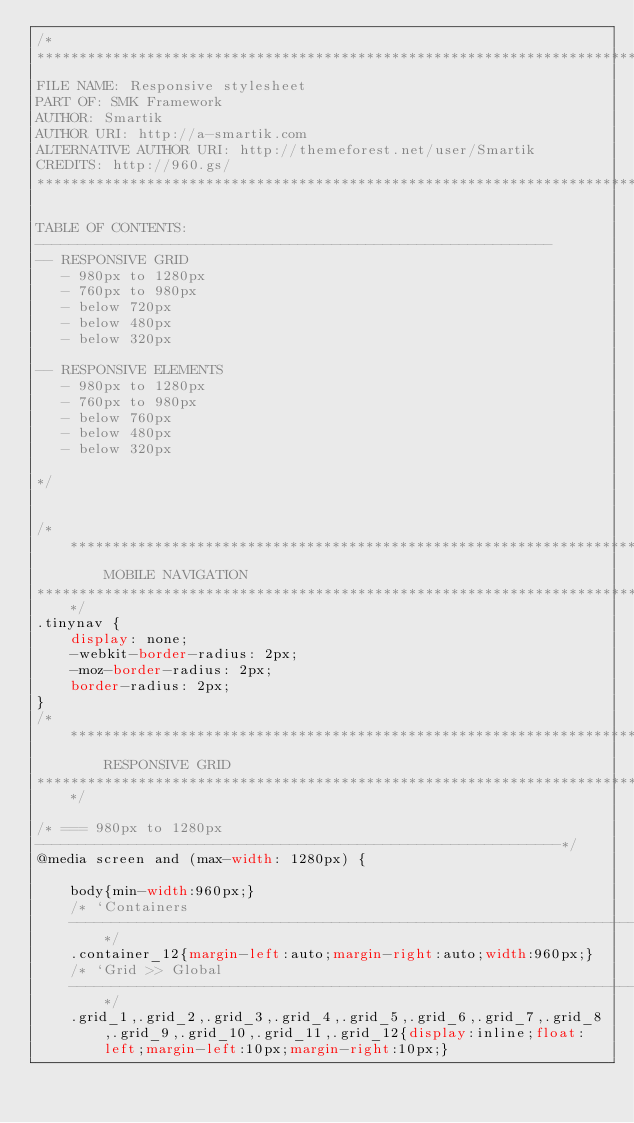Convert code to text. <code><loc_0><loc_0><loc_500><loc_500><_CSS_>/*
************************************************************************
FILE NAME: Responsive stylesheet
PART OF: SMK Framework
AUTHOR: Smartik
AUTHOR URI: http://a-smartik.com
ALTERNATIVE AUTHOR URI: http://themeforest.net/user/Smartik
CREDITS: http://960.gs/
************************************************************************

TABLE OF CONTENTS:
-------------------------------------------------------------
-- RESPONSIVE GRID
   - 980px to 1280px
   - 760px to 980px
   - below 720px
   - below 480px
   - below 320px

-- RESPONSIVE ELEMENTS
   - 980px to 1280px
   - 760px to 980px
   - below 760px
   - below 480px
   - below 320px

*/


/****************************************************************************
        MOBILE NAVIGATION
*****************************************************************************/
.tinynav {
    display: none;
    -webkit-border-radius: 2px;
    -moz-border-radius: 2px;
    border-radius: 2px;
}
/***********************************************************************************
        RESPONSIVE GRID
************************************************************************************/

/* === 980px to 1280px
--------------------------------------------------------------*/
@media screen and (max-width: 1280px) {

    body{min-width:960px;}
    /* `Containers
    ----------------------------------------------------------------------------------------------------*/
    .container_12{margin-left:auto;margin-right:auto;width:960px;}
    /* `Grid >> Global
    ----------------------------------------------------------------------------------------------------*/
    .grid_1,.grid_2,.grid_3,.grid_4,.grid_5,.grid_6,.grid_7,.grid_8,.grid_9,.grid_10,.grid_11,.grid_12{display:inline;float:left;margin-left:10px;margin-right:10px;}</code> 